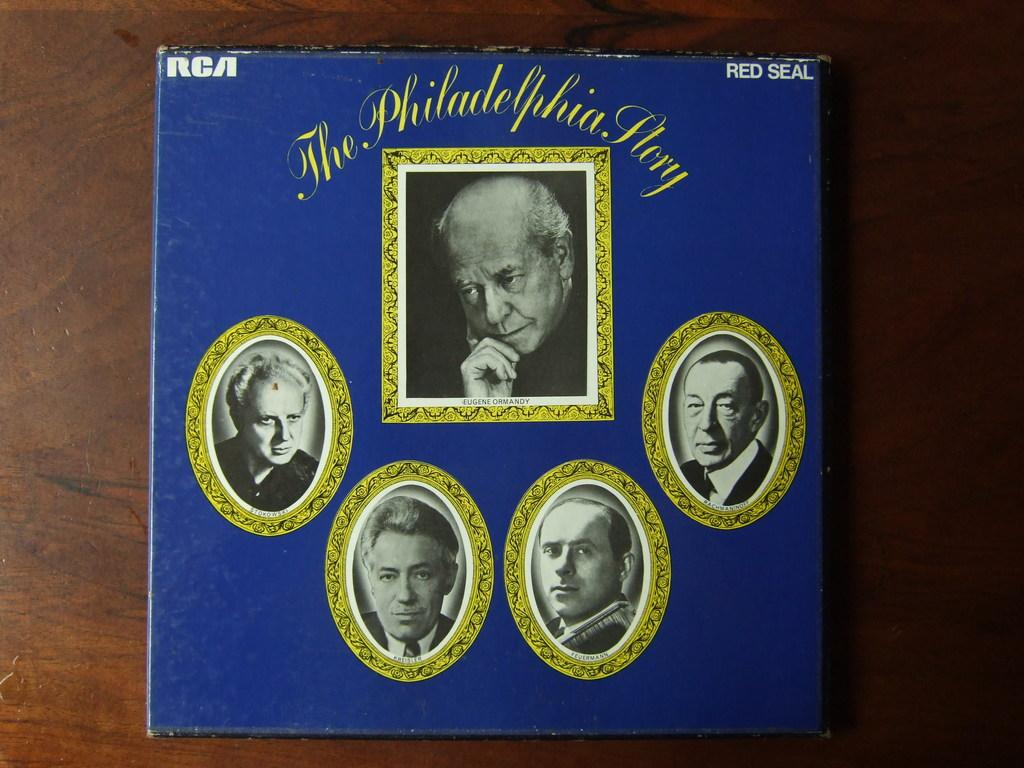What color is the object in the image? The object in the image is blue. What type of object is it? The object appears to be a book or book-like. On what surface is the object placed? The object is on a wooden surface. What can be found on the object? There are pictures and text on the object. What role does the object play in the war depicted in the image? There is no war depicted in the image, and the object does not play a role in any war. How does the object aid in the digestion process? The object is a book or book-like, and it does not aid in the digestion process. 